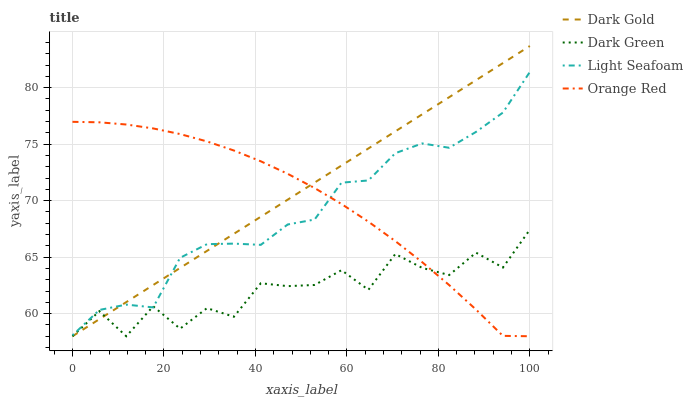Does Dark Green have the minimum area under the curve?
Answer yes or no. Yes. Does Dark Gold have the maximum area under the curve?
Answer yes or no. Yes. Does Orange Red have the minimum area under the curve?
Answer yes or no. No. Does Orange Red have the maximum area under the curve?
Answer yes or no. No. Is Dark Gold the smoothest?
Answer yes or no. Yes. Is Dark Green the roughest?
Answer yes or no. Yes. Is Orange Red the smoothest?
Answer yes or no. No. Is Orange Red the roughest?
Answer yes or no. No. Does Light Seafoam have the lowest value?
Answer yes or no. No. Does Dark Gold have the highest value?
Answer yes or no. Yes. Does Orange Red have the highest value?
Answer yes or no. No. Does Light Seafoam intersect Dark Gold?
Answer yes or no. Yes. Is Light Seafoam less than Dark Gold?
Answer yes or no. No. Is Light Seafoam greater than Dark Gold?
Answer yes or no. No. 